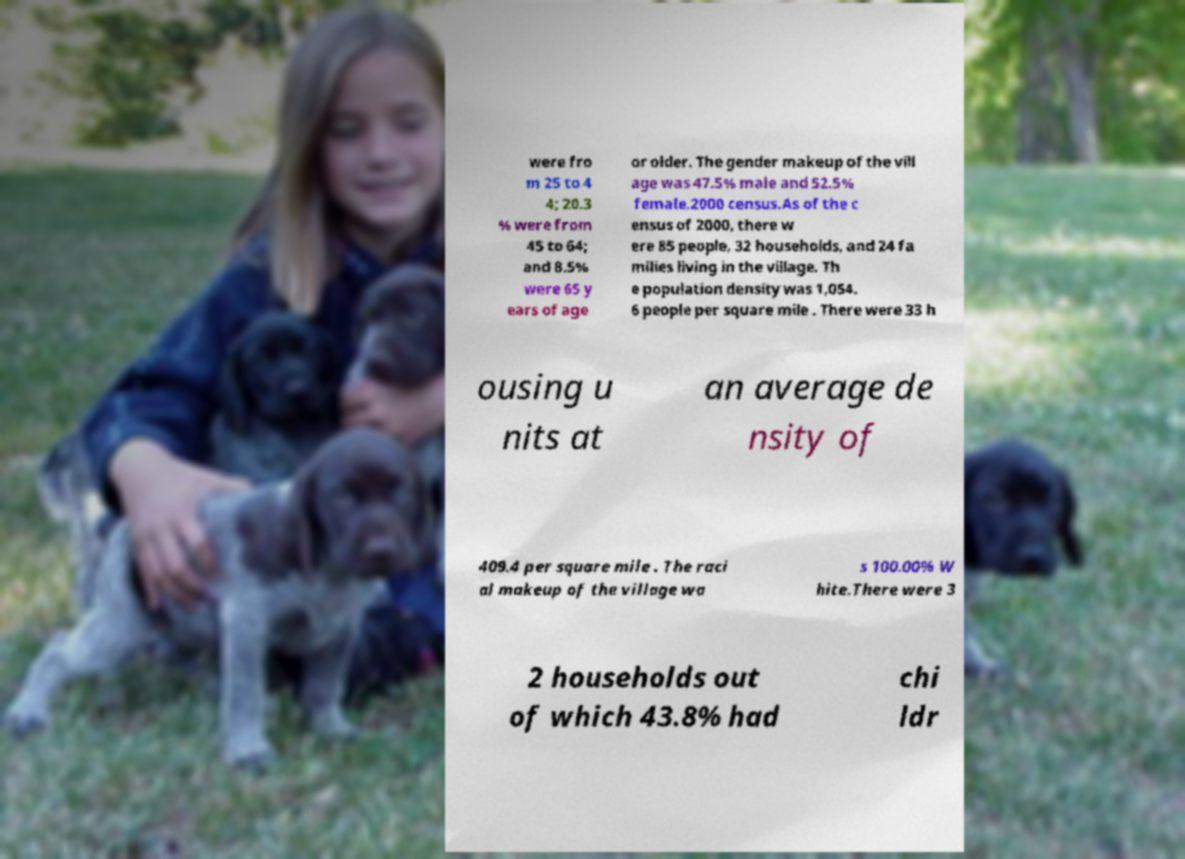Could you extract and type out the text from this image? were fro m 25 to 4 4; 20.3 % were from 45 to 64; and 8.5% were 65 y ears of age or older. The gender makeup of the vill age was 47.5% male and 52.5% female.2000 census.As of the c ensus of 2000, there w ere 85 people, 32 households, and 24 fa milies living in the village. Th e population density was 1,054. 6 people per square mile . There were 33 h ousing u nits at an average de nsity of 409.4 per square mile . The raci al makeup of the village wa s 100.00% W hite.There were 3 2 households out of which 43.8% had chi ldr 